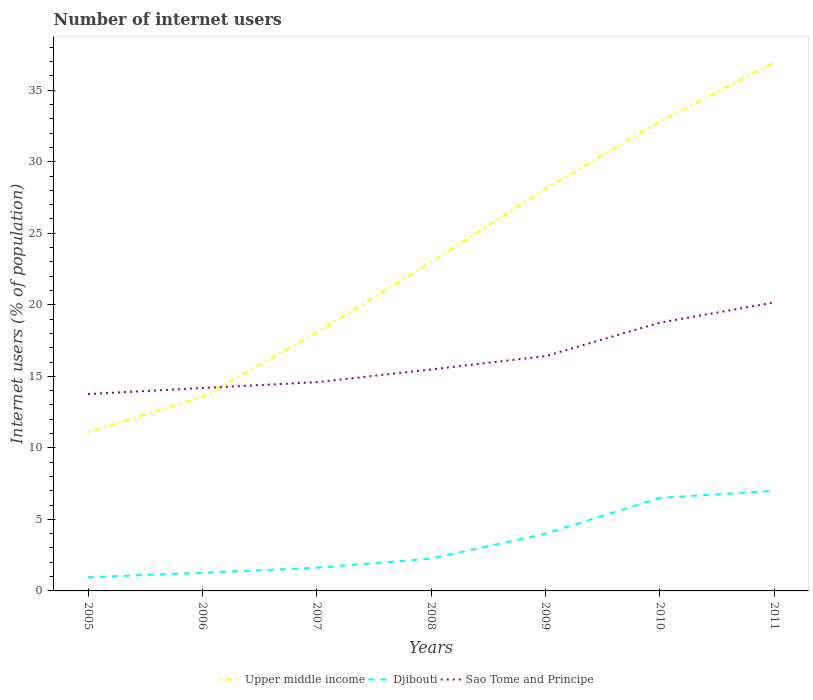Is the number of lines equal to the number of legend labels?
Make the answer very short. Yes. Across all years, what is the maximum number of internet users in Sao Tome and Principe?
Ensure brevity in your answer.  13.76. What is the total number of internet users in Djibouti in the graph?
Provide a short and direct response. -1.74. What is the difference between the highest and the second highest number of internet users in Upper middle income?
Give a very brief answer. 25.86. What is the difference between the highest and the lowest number of internet users in Sao Tome and Principe?
Your answer should be compact. 3. How many lines are there?
Offer a terse response. 3. How many years are there in the graph?
Give a very brief answer. 7. Are the values on the major ticks of Y-axis written in scientific E-notation?
Provide a short and direct response. No. Does the graph contain grids?
Your answer should be very brief. No. What is the title of the graph?
Provide a short and direct response. Number of internet users. What is the label or title of the X-axis?
Offer a very short reply. Years. What is the label or title of the Y-axis?
Your response must be concise. Internet users (% of population). What is the Internet users (% of population) in Upper middle income in 2005?
Give a very brief answer. 11.08. What is the Internet users (% of population) in Djibouti in 2005?
Make the answer very short. 0.95. What is the Internet users (% of population) in Sao Tome and Principe in 2005?
Give a very brief answer. 13.76. What is the Internet users (% of population) in Upper middle income in 2006?
Provide a short and direct response. 13.56. What is the Internet users (% of population) of Djibouti in 2006?
Provide a short and direct response. 1.27. What is the Internet users (% of population) in Sao Tome and Principe in 2006?
Make the answer very short. 14.18. What is the Internet users (% of population) of Upper middle income in 2007?
Ensure brevity in your answer.  18.05. What is the Internet users (% of population) in Djibouti in 2007?
Give a very brief answer. 1.62. What is the Internet users (% of population) in Sao Tome and Principe in 2007?
Provide a succinct answer. 14.59. What is the Internet users (% of population) of Upper middle income in 2008?
Your response must be concise. 22.99. What is the Internet users (% of population) of Djibouti in 2008?
Ensure brevity in your answer.  2.26. What is the Internet users (% of population) in Sao Tome and Principe in 2008?
Keep it short and to the point. 15.48. What is the Internet users (% of population) in Upper middle income in 2009?
Make the answer very short. 28.1. What is the Internet users (% of population) of Sao Tome and Principe in 2009?
Provide a succinct answer. 16.41. What is the Internet users (% of population) in Upper middle income in 2010?
Make the answer very short. 32.81. What is the Internet users (% of population) in Sao Tome and Principe in 2010?
Make the answer very short. 18.75. What is the Internet users (% of population) of Upper middle income in 2011?
Offer a terse response. 36.95. What is the Internet users (% of population) of Djibouti in 2011?
Make the answer very short. 7. What is the Internet users (% of population) in Sao Tome and Principe in 2011?
Your answer should be compact. 20.16. Across all years, what is the maximum Internet users (% of population) of Upper middle income?
Provide a short and direct response. 36.95. Across all years, what is the maximum Internet users (% of population) of Djibouti?
Offer a very short reply. 7. Across all years, what is the maximum Internet users (% of population) in Sao Tome and Principe?
Your answer should be very brief. 20.16. Across all years, what is the minimum Internet users (% of population) in Upper middle income?
Your answer should be compact. 11.08. Across all years, what is the minimum Internet users (% of population) of Djibouti?
Offer a very short reply. 0.95. Across all years, what is the minimum Internet users (% of population) of Sao Tome and Principe?
Give a very brief answer. 13.76. What is the total Internet users (% of population) of Upper middle income in the graph?
Offer a very short reply. 163.54. What is the total Internet users (% of population) in Djibouti in the graph?
Give a very brief answer. 23.6. What is the total Internet users (% of population) in Sao Tome and Principe in the graph?
Offer a terse response. 113.33. What is the difference between the Internet users (% of population) of Upper middle income in 2005 and that in 2006?
Ensure brevity in your answer.  -2.47. What is the difference between the Internet users (% of population) of Djibouti in 2005 and that in 2006?
Your answer should be very brief. -0.32. What is the difference between the Internet users (% of population) of Sao Tome and Principe in 2005 and that in 2006?
Ensure brevity in your answer.  -0.42. What is the difference between the Internet users (% of population) in Upper middle income in 2005 and that in 2007?
Your response must be concise. -6.97. What is the difference between the Internet users (% of population) in Djibouti in 2005 and that in 2007?
Your answer should be very brief. -0.67. What is the difference between the Internet users (% of population) in Sao Tome and Principe in 2005 and that in 2007?
Make the answer very short. -0.83. What is the difference between the Internet users (% of population) of Upper middle income in 2005 and that in 2008?
Ensure brevity in your answer.  -11.91. What is the difference between the Internet users (% of population) of Djibouti in 2005 and that in 2008?
Provide a short and direct response. -1.31. What is the difference between the Internet users (% of population) of Sao Tome and Principe in 2005 and that in 2008?
Offer a very short reply. -1.72. What is the difference between the Internet users (% of population) in Upper middle income in 2005 and that in 2009?
Ensure brevity in your answer.  -17.02. What is the difference between the Internet users (% of population) in Djibouti in 2005 and that in 2009?
Your answer should be very brief. -3.05. What is the difference between the Internet users (% of population) of Sao Tome and Principe in 2005 and that in 2009?
Ensure brevity in your answer.  -2.65. What is the difference between the Internet users (% of population) in Upper middle income in 2005 and that in 2010?
Keep it short and to the point. -21.72. What is the difference between the Internet users (% of population) in Djibouti in 2005 and that in 2010?
Make the answer very short. -5.55. What is the difference between the Internet users (% of population) of Sao Tome and Principe in 2005 and that in 2010?
Your response must be concise. -4.99. What is the difference between the Internet users (% of population) of Upper middle income in 2005 and that in 2011?
Offer a very short reply. -25.86. What is the difference between the Internet users (% of population) of Djibouti in 2005 and that in 2011?
Your response must be concise. -6.05. What is the difference between the Internet users (% of population) in Sao Tome and Principe in 2005 and that in 2011?
Make the answer very short. -6.4. What is the difference between the Internet users (% of population) of Upper middle income in 2006 and that in 2007?
Give a very brief answer. -4.49. What is the difference between the Internet users (% of population) in Djibouti in 2006 and that in 2007?
Provide a succinct answer. -0.35. What is the difference between the Internet users (% of population) of Sao Tome and Principe in 2006 and that in 2007?
Offer a very short reply. -0.41. What is the difference between the Internet users (% of population) in Upper middle income in 2006 and that in 2008?
Your answer should be compact. -9.43. What is the difference between the Internet users (% of population) in Djibouti in 2006 and that in 2008?
Offer a terse response. -0.99. What is the difference between the Internet users (% of population) in Sao Tome and Principe in 2006 and that in 2008?
Provide a succinct answer. -1.3. What is the difference between the Internet users (% of population) in Upper middle income in 2006 and that in 2009?
Provide a short and direct response. -14.54. What is the difference between the Internet users (% of population) in Djibouti in 2006 and that in 2009?
Your response must be concise. -2.73. What is the difference between the Internet users (% of population) of Sao Tome and Principe in 2006 and that in 2009?
Make the answer very short. -2.23. What is the difference between the Internet users (% of population) in Upper middle income in 2006 and that in 2010?
Offer a terse response. -19.25. What is the difference between the Internet users (% of population) of Djibouti in 2006 and that in 2010?
Offer a very short reply. -5.23. What is the difference between the Internet users (% of population) in Sao Tome and Principe in 2006 and that in 2010?
Provide a short and direct response. -4.57. What is the difference between the Internet users (% of population) of Upper middle income in 2006 and that in 2011?
Your answer should be very brief. -23.39. What is the difference between the Internet users (% of population) in Djibouti in 2006 and that in 2011?
Offer a very short reply. -5.73. What is the difference between the Internet users (% of population) in Sao Tome and Principe in 2006 and that in 2011?
Keep it short and to the point. -5.98. What is the difference between the Internet users (% of population) of Upper middle income in 2007 and that in 2008?
Offer a terse response. -4.94. What is the difference between the Internet users (% of population) in Djibouti in 2007 and that in 2008?
Provide a succinct answer. -0.64. What is the difference between the Internet users (% of population) in Sao Tome and Principe in 2007 and that in 2008?
Your answer should be compact. -0.89. What is the difference between the Internet users (% of population) of Upper middle income in 2007 and that in 2009?
Ensure brevity in your answer.  -10.05. What is the difference between the Internet users (% of population) in Djibouti in 2007 and that in 2009?
Give a very brief answer. -2.38. What is the difference between the Internet users (% of population) of Sao Tome and Principe in 2007 and that in 2009?
Offer a very short reply. -1.82. What is the difference between the Internet users (% of population) of Upper middle income in 2007 and that in 2010?
Keep it short and to the point. -14.76. What is the difference between the Internet users (% of population) in Djibouti in 2007 and that in 2010?
Offer a terse response. -4.88. What is the difference between the Internet users (% of population) in Sao Tome and Principe in 2007 and that in 2010?
Your answer should be compact. -4.16. What is the difference between the Internet users (% of population) in Upper middle income in 2007 and that in 2011?
Your answer should be compact. -18.9. What is the difference between the Internet users (% of population) of Djibouti in 2007 and that in 2011?
Offer a terse response. -5.38. What is the difference between the Internet users (% of population) in Sao Tome and Principe in 2007 and that in 2011?
Provide a short and direct response. -5.57. What is the difference between the Internet users (% of population) of Upper middle income in 2008 and that in 2009?
Offer a terse response. -5.11. What is the difference between the Internet users (% of population) in Djibouti in 2008 and that in 2009?
Provide a succinct answer. -1.74. What is the difference between the Internet users (% of population) in Sao Tome and Principe in 2008 and that in 2009?
Your answer should be very brief. -0.93. What is the difference between the Internet users (% of population) of Upper middle income in 2008 and that in 2010?
Keep it short and to the point. -9.82. What is the difference between the Internet users (% of population) of Djibouti in 2008 and that in 2010?
Your answer should be compact. -4.24. What is the difference between the Internet users (% of population) of Sao Tome and Principe in 2008 and that in 2010?
Make the answer very short. -3.27. What is the difference between the Internet users (% of population) of Upper middle income in 2008 and that in 2011?
Provide a succinct answer. -13.96. What is the difference between the Internet users (% of population) in Djibouti in 2008 and that in 2011?
Give a very brief answer. -4.74. What is the difference between the Internet users (% of population) in Sao Tome and Principe in 2008 and that in 2011?
Ensure brevity in your answer.  -4.68. What is the difference between the Internet users (% of population) in Upper middle income in 2009 and that in 2010?
Keep it short and to the point. -4.7. What is the difference between the Internet users (% of population) in Sao Tome and Principe in 2009 and that in 2010?
Provide a short and direct response. -2.34. What is the difference between the Internet users (% of population) in Upper middle income in 2009 and that in 2011?
Your response must be concise. -8.84. What is the difference between the Internet users (% of population) of Djibouti in 2009 and that in 2011?
Keep it short and to the point. -3. What is the difference between the Internet users (% of population) in Sao Tome and Principe in 2009 and that in 2011?
Make the answer very short. -3.75. What is the difference between the Internet users (% of population) of Upper middle income in 2010 and that in 2011?
Give a very brief answer. -4.14. What is the difference between the Internet users (% of population) in Sao Tome and Principe in 2010 and that in 2011?
Offer a terse response. -1.41. What is the difference between the Internet users (% of population) of Upper middle income in 2005 and the Internet users (% of population) of Djibouti in 2006?
Your answer should be very brief. 9.81. What is the difference between the Internet users (% of population) of Upper middle income in 2005 and the Internet users (% of population) of Sao Tome and Principe in 2006?
Give a very brief answer. -3.1. What is the difference between the Internet users (% of population) in Djibouti in 2005 and the Internet users (% of population) in Sao Tome and Principe in 2006?
Ensure brevity in your answer.  -13.23. What is the difference between the Internet users (% of population) of Upper middle income in 2005 and the Internet users (% of population) of Djibouti in 2007?
Your answer should be very brief. 9.46. What is the difference between the Internet users (% of population) of Upper middle income in 2005 and the Internet users (% of population) of Sao Tome and Principe in 2007?
Your answer should be very brief. -3.51. What is the difference between the Internet users (% of population) of Djibouti in 2005 and the Internet users (% of population) of Sao Tome and Principe in 2007?
Ensure brevity in your answer.  -13.64. What is the difference between the Internet users (% of population) in Upper middle income in 2005 and the Internet users (% of population) in Djibouti in 2008?
Offer a very short reply. 8.82. What is the difference between the Internet users (% of population) in Upper middle income in 2005 and the Internet users (% of population) in Sao Tome and Principe in 2008?
Provide a succinct answer. -4.4. What is the difference between the Internet users (% of population) in Djibouti in 2005 and the Internet users (% of population) in Sao Tome and Principe in 2008?
Make the answer very short. -14.53. What is the difference between the Internet users (% of population) in Upper middle income in 2005 and the Internet users (% of population) in Djibouti in 2009?
Provide a succinct answer. 7.08. What is the difference between the Internet users (% of population) in Upper middle income in 2005 and the Internet users (% of population) in Sao Tome and Principe in 2009?
Your response must be concise. -5.33. What is the difference between the Internet users (% of population) of Djibouti in 2005 and the Internet users (% of population) of Sao Tome and Principe in 2009?
Give a very brief answer. -15.46. What is the difference between the Internet users (% of population) in Upper middle income in 2005 and the Internet users (% of population) in Djibouti in 2010?
Make the answer very short. 4.58. What is the difference between the Internet users (% of population) in Upper middle income in 2005 and the Internet users (% of population) in Sao Tome and Principe in 2010?
Provide a succinct answer. -7.67. What is the difference between the Internet users (% of population) of Djibouti in 2005 and the Internet users (% of population) of Sao Tome and Principe in 2010?
Offer a very short reply. -17.8. What is the difference between the Internet users (% of population) in Upper middle income in 2005 and the Internet users (% of population) in Djibouti in 2011?
Ensure brevity in your answer.  4.08. What is the difference between the Internet users (% of population) of Upper middle income in 2005 and the Internet users (% of population) of Sao Tome and Principe in 2011?
Your answer should be compact. -9.08. What is the difference between the Internet users (% of population) of Djibouti in 2005 and the Internet users (% of population) of Sao Tome and Principe in 2011?
Offer a very short reply. -19.21. What is the difference between the Internet users (% of population) in Upper middle income in 2006 and the Internet users (% of population) in Djibouti in 2007?
Ensure brevity in your answer.  11.94. What is the difference between the Internet users (% of population) of Upper middle income in 2006 and the Internet users (% of population) of Sao Tome and Principe in 2007?
Your answer should be very brief. -1.03. What is the difference between the Internet users (% of population) in Djibouti in 2006 and the Internet users (% of population) in Sao Tome and Principe in 2007?
Provide a succinct answer. -13.32. What is the difference between the Internet users (% of population) of Upper middle income in 2006 and the Internet users (% of population) of Djibouti in 2008?
Offer a very short reply. 11.3. What is the difference between the Internet users (% of population) in Upper middle income in 2006 and the Internet users (% of population) in Sao Tome and Principe in 2008?
Your answer should be compact. -1.92. What is the difference between the Internet users (% of population) in Djibouti in 2006 and the Internet users (% of population) in Sao Tome and Principe in 2008?
Make the answer very short. -14.21. What is the difference between the Internet users (% of population) of Upper middle income in 2006 and the Internet users (% of population) of Djibouti in 2009?
Your response must be concise. 9.56. What is the difference between the Internet users (% of population) of Upper middle income in 2006 and the Internet users (% of population) of Sao Tome and Principe in 2009?
Your answer should be compact. -2.85. What is the difference between the Internet users (% of population) of Djibouti in 2006 and the Internet users (% of population) of Sao Tome and Principe in 2009?
Offer a very short reply. -15.14. What is the difference between the Internet users (% of population) of Upper middle income in 2006 and the Internet users (% of population) of Djibouti in 2010?
Provide a succinct answer. 7.06. What is the difference between the Internet users (% of population) in Upper middle income in 2006 and the Internet users (% of population) in Sao Tome and Principe in 2010?
Your answer should be compact. -5.19. What is the difference between the Internet users (% of population) of Djibouti in 2006 and the Internet users (% of population) of Sao Tome and Principe in 2010?
Your response must be concise. -17.48. What is the difference between the Internet users (% of population) of Upper middle income in 2006 and the Internet users (% of population) of Djibouti in 2011?
Your response must be concise. 6.56. What is the difference between the Internet users (% of population) of Upper middle income in 2006 and the Internet users (% of population) of Sao Tome and Principe in 2011?
Your response must be concise. -6.6. What is the difference between the Internet users (% of population) of Djibouti in 2006 and the Internet users (% of population) of Sao Tome and Principe in 2011?
Make the answer very short. -18.89. What is the difference between the Internet users (% of population) of Upper middle income in 2007 and the Internet users (% of population) of Djibouti in 2008?
Provide a short and direct response. 15.79. What is the difference between the Internet users (% of population) in Upper middle income in 2007 and the Internet users (% of population) in Sao Tome and Principe in 2008?
Offer a very short reply. 2.57. What is the difference between the Internet users (% of population) of Djibouti in 2007 and the Internet users (% of population) of Sao Tome and Principe in 2008?
Keep it short and to the point. -13.86. What is the difference between the Internet users (% of population) in Upper middle income in 2007 and the Internet users (% of population) in Djibouti in 2009?
Give a very brief answer. 14.05. What is the difference between the Internet users (% of population) of Upper middle income in 2007 and the Internet users (% of population) of Sao Tome and Principe in 2009?
Ensure brevity in your answer.  1.64. What is the difference between the Internet users (% of population) of Djibouti in 2007 and the Internet users (% of population) of Sao Tome and Principe in 2009?
Your answer should be very brief. -14.79. What is the difference between the Internet users (% of population) in Upper middle income in 2007 and the Internet users (% of population) in Djibouti in 2010?
Make the answer very short. 11.55. What is the difference between the Internet users (% of population) in Upper middle income in 2007 and the Internet users (% of population) in Sao Tome and Principe in 2010?
Your response must be concise. -0.7. What is the difference between the Internet users (% of population) in Djibouti in 2007 and the Internet users (% of population) in Sao Tome and Principe in 2010?
Ensure brevity in your answer.  -17.13. What is the difference between the Internet users (% of population) of Upper middle income in 2007 and the Internet users (% of population) of Djibouti in 2011?
Ensure brevity in your answer.  11.05. What is the difference between the Internet users (% of population) in Upper middle income in 2007 and the Internet users (% of population) in Sao Tome and Principe in 2011?
Provide a succinct answer. -2.11. What is the difference between the Internet users (% of population) of Djibouti in 2007 and the Internet users (% of population) of Sao Tome and Principe in 2011?
Provide a short and direct response. -18.54. What is the difference between the Internet users (% of population) of Upper middle income in 2008 and the Internet users (% of population) of Djibouti in 2009?
Provide a succinct answer. 18.99. What is the difference between the Internet users (% of population) of Upper middle income in 2008 and the Internet users (% of population) of Sao Tome and Principe in 2009?
Keep it short and to the point. 6.58. What is the difference between the Internet users (% of population) of Djibouti in 2008 and the Internet users (% of population) of Sao Tome and Principe in 2009?
Provide a succinct answer. -14.15. What is the difference between the Internet users (% of population) in Upper middle income in 2008 and the Internet users (% of population) in Djibouti in 2010?
Make the answer very short. 16.49. What is the difference between the Internet users (% of population) in Upper middle income in 2008 and the Internet users (% of population) in Sao Tome and Principe in 2010?
Your answer should be very brief. 4.24. What is the difference between the Internet users (% of population) of Djibouti in 2008 and the Internet users (% of population) of Sao Tome and Principe in 2010?
Ensure brevity in your answer.  -16.49. What is the difference between the Internet users (% of population) in Upper middle income in 2008 and the Internet users (% of population) in Djibouti in 2011?
Your answer should be compact. 15.99. What is the difference between the Internet users (% of population) in Upper middle income in 2008 and the Internet users (% of population) in Sao Tome and Principe in 2011?
Ensure brevity in your answer.  2.83. What is the difference between the Internet users (% of population) of Djibouti in 2008 and the Internet users (% of population) of Sao Tome and Principe in 2011?
Give a very brief answer. -17.9. What is the difference between the Internet users (% of population) of Upper middle income in 2009 and the Internet users (% of population) of Djibouti in 2010?
Offer a very short reply. 21.6. What is the difference between the Internet users (% of population) of Upper middle income in 2009 and the Internet users (% of population) of Sao Tome and Principe in 2010?
Make the answer very short. 9.35. What is the difference between the Internet users (% of population) of Djibouti in 2009 and the Internet users (% of population) of Sao Tome and Principe in 2010?
Provide a succinct answer. -14.75. What is the difference between the Internet users (% of population) in Upper middle income in 2009 and the Internet users (% of population) in Djibouti in 2011?
Keep it short and to the point. 21.1. What is the difference between the Internet users (% of population) of Upper middle income in 2009 and the Internet users (% of population) of Sao Tome and Principe in 2011?
Offer a terse response. 7.94. What is the difference between the Internet users (% of population) of Djibouti in 2009 and the Internet users (% of population) of Sao Tome and Principe in 2011?
Ensure brevity in your answer.  -16.16. What is the difference between the Internet users (% of population) in Upper middle income in 2010 and the Internet users (% of population) in Djibouti in 2011?
Offer a terse response. 25.81. What is the difference between the Internet users (% of population) in Upper middle income in 2010 and the Internet users (% of population) in Sao Tome and Principe in 2011?
Keep it short and to the point. 12.64. What is the difference between the Internet users (% of population) of Djibouti in 2010 and the Internet users (% of population) of Sao Tome and Principe in 2011?
Offer a terse response. -13.66. What is the average Internet users (% of population) in Upper middle income per year?
Your response must be concise. 23.36. What is the average Internet users (% of population) in Djibouti per year?
Make the answer very short. 3.37. What is the average Internet users (% of population) of Sao Tome and Principe per year?
Ensure brevity in your answer.  16.19. In the year 2005, what is the difference between the Internet users (% of population) of Upper middle income and Internet users (% of population) of Djibouti?
Provide a short and direct response. 10.13. In the year 2005, what is the difference between the Internet users (% of population) of Upper middle income and Internet users (% of population) of Sao Tome and Principe?
Provide a succinct answer. -2.67. In the year 2005, what is the difference between the Internet users (% of population) of Djibouti and Internet users (% of population) of Sao Tome and Principe?
Offer a terse response. -12.81. In the year 2006, what is the difference between the Internet users (% of population) in Upper middle income and Internet users (% of population) in Djibouti?
Your answer should be very brief. 12.29. In the year 2006, what is the difference between the Internet users (% of population) of Upper middle income and Internet users (% of population) of Sao Tome and Principe?
Your response must be concise. -0.62. In the year 2006, what is the difference between the Internet users (% of population) of Djibouti and Internet users (% of population) of Sao Tome and Principe?
Offer a terse response. -12.91. In the year 2007, what is the difference between the Internet users (% of population) in Upper middle income and Internet users (% of population) in Djibouti?
Offer a very short reply. 16.43. In the year 2007, what is the difference between the Internet users (% of population) of Upper middle income and Internet users (% of population) of Sao Tome and Principe?
Provide a short and direct response. 3.46. In the year 2007, what is the difference between the Internet users (% of population) of Djibouti and Internet users (% of population) of Sao Tome and Principe?
Your answer should be compact. -12.97. In the year 2008, what is the difference between the Internet users (% of population) of Upper middle income and Internet users (% of population) of Djibouti?
Make the answer very short. 20.73. In the year 2008, what is the difference between the Internet users (% of population) in Upper middle income and Internet users (% of population) in Sao Tome and Principe?
Provide a succinct answer. 7.51. In the year 2008, what is the difference between the Internet users (% of population) of Djibouti and Internet users (% of population) of Sao Tome and Principe?
Offer a very short reply. -13.22. In the year 2009, what is the difference between the Internet users (% of population) in Upper middle income and Internet users (% of population) in Djibouti?
Give a very brief answer. 24.1. In the year 2009, what is the difference between the Internet users (% of population) of Upper middle income and Internet users (% of population) of Sao Tome and Principe?
Your answer should be very brief. 11.69. In the year 2009, what is the difference between the Internet users (% of population) in Djibouti and Internet users (% of population) in Sao Tome and Principe?
Your answer should be very brief. -12.41. In the year 2010, what is the difference between the Internet users (% of population) of Upper middle income and Internet users (% of population) of Djibouti?
Your response must be concise. 26.31. In the year 2010, what is the difference between the Internet users (% of population) in Upper middle income and Internet users (% of population) in Sao Tome and Principe?
Your answer should be compact. 14.06. In the year 2010, what is the difference between the Internet users (% of population) of Djibouti and Internet users (% of population) of Sao Tome and Principe?
Make the answer very short. -12.25. In the year 2011, what is the difference between the Internet users (% of population) of Upper middle income and Internet users (% of population) of Djibouti?
Your answer should be very brief. 29.95. In the year 2011, what is the difference between the Internet users (% of population) of Upper middle income and Internet users (% of population) of Sao Tome and Principe?
Offer a very short reply. 16.78. In the year 2011, what is the difference between the Internet users (% of population) of Djibouti and Internet users (% of population) of Sao Tome and Principe?
Provide a succinct answer. -13.16. What is the ratio of the Internet users (% of population) of Upper middle income in 2005 to that in 2006?
Make the answer very short. 0.82. What is the ratio of the Internet users (% of population) in Djibouti in 2005 to that in 2006?
Your response must be concise. 0.75. What is the ratio of the Internet users (% of population) of Sao Tome and Principe in 2005 to that in 2006?
Ensure brevity in your answer.  0.97. What is the ratio of the Internet users (% of population) of Upper middle income in 2005 to that in 2007?
Offer a very short reply. 0.61. What is the ratio of the Internet users (% of population) in Djibouti in 2005 to that in 2007?
Ensure brevity in your answer.  0.59. What is the ratio of the Internet users (% of population) of Sao Tome and Principe in 2005 to that in 2007?
Make the answer very short. 0.94. What is the ratio of the Internet users (% of population) of Upper middle income in 2005 to that in 2008?
Ensure brevity in your answer.  0.48. What is the ratio of the Internet users (% of population) of Djibouti in 2005 to that in 2008?
Provide a short and direct response. 0.42. What is the ratio of the Internet users (% of population) in Upper middle income in 2005 to that in 2009?
Make the answer very short. 0.39. What is the ratio of the Internet users (% of population) of Djibouti in 2005 to that in 2009?
Your response must be concise. 0.24. What is the ratio of the Internet users (% of population) in Sao Tome and Principe in 2005 to that in 2009?
Your answer should be very brief. 0.84. What is the ratio of the Internet users (% of population) in Upper middle income in 2005 to that in 2010?
Keep it short and to the point. 0.34. What is the ratio of the Internet users (% of population) of Djibouti in 2005 to that in 2010?
Offer a very short reply. 0.15. What is the ratio of the Internet users (% of population) in Sao Tome and Principe in 2005 to that in 2010?
Your answer should be compact. 0.73. What is the ratio of the Internet users (% of population) of Djibouti in 2005 to that in 2011?
Your response must be concise. 0.14. What is the ratio of the Internet users (% of population) in Sao Tome and Principe in 2005 to that in 2011?
Ensure brevity in your answer.  0.68. What is the ratio of the Internet users (% of population) of Upper middle income in 2006 to that in 2007?
Your answer should be very brief. 0.75. What is the ratio of the Internet users (% of population) of Djibouti in 2006 to that in 2007?
Your response must be concise. 0.78. What is the ratio of the Internet users (% of population) of Sao Tome and Principe in 2006 to that in 2007?
Make the answer very short. 0.97. What is the ratio of the Internet users (% of population) of Upper middle income in 2006 to that in 2008?
Give a very brief answer. 0.59. What is the ratio of the Internet users (% of population) in Djibouti in 2006 to that in 2008?
Give a very brief answer. 0.56. What is the ratio of the Internet users (% of population) in Sao Tome and Principe in 2006 to that in 2008?
Your answer should be compact. 0.92. What is the ratio of the Internet users (% of population) of Upper middle income in 2006 to that in 2009?
Offer a very short reply. 0.48. What is the ratio of the Internet users (% of population) of Djibouti in 2006 to that in 2009?
Your answer should be very brief. 0.32. What is the ratio of the Internet users (% of population) of Sao Tome and Principe in 2006 to that in 2009?
Your answer should be compact. 0.86. What is the ratio of the Internet users (% of population) in Upper middle income in 2006 to that in 2010?
Give a very brief answer. 0.41. What is the ratio of the Internet users (% of population) of Djibouti in 2006 to that in 2010?
Give a very brief answer. 0.2. What is the ratio of the Internet users (% of population) in Sao Tome and Principe in 2006 to that in 2010?
Provide a short and direct response. 0.76. What is the ratio of the Internet users (% of population) in Upper middle income in 2006 to that in 2011?
Your response must be concise. 0.37. What is the ratio of the Internet users (% of population) of Djibouti in 2006 to that in 2011?
Offer a very short reply. 0.18. What is the ratio of the Internet users (% of population) of Sao Tome and Principe in 2006 to that in 2011?
Give a very brief answer. 0.7. What is the ratio of the Internet users (% of population) of Upper middle income in 2007 to that in 2008?
Your response must be concise. 0.79. What is the ratio of the Internet users (% of population) of Djibouti in 2007 to that in 2008?
Your answer should be very brief. 0.72. What is the ratio of the Internet users (% of population) of Sao Tome and Principe in 2007 to that in 2008?
Offer a terse response. 0.94. What is the ratio of the Internet users (% of population) in Upper middle income in 2007 to that in 2009?
Provide a succinct answer. 0.64. What is the ratio of the Internet users (% of population) of Djibouti in 2007 to that in 2009?
Keep it short and to the point. 0.41. What is the ratio of the Internet users (% of population) in Sao Tome and Principe in 2007 to that in 2009?
Your answer should be very brief. 0.89. What is the ratio of the Internet users (% of population) in Upper middle income in 2007 to that in 2010?
Offer a terse response. 0.55. What is the ratio of the Internet users (% of population) in Djibouti in 2007 to that in 2010?
Offer a very short reply. 0.25. What is the ratio of the Internet users (% of population) of Sao Tome and Principe in 2007 to that in 2010?
Provide a succinct answer. 0.78. What is the ratio of the Internet users (% of population) of Upper middle income in 2007 to that in 2011?
Make the answer very short. 0.49. What is the ratio of the Internet users (% of population) in Djibouti in 2007 to that in 2011?
Offer a terse response. 0.23. What is the ratio of the Internet users (% of population) in Sao Tome and Principe in 2007 to that in 2011?
Ensure brevity in your answer.  0.72. What is the ratio of the Internet users (% of population) of Upper middle income in 2008 to that in 2009?
Your answer should be very brief. 0.82. What is the ratio of the Internet users (% of population) of Djibouti in 2008 to that in 2009?
Keep it short and to the point. 0.56. What is the ratio of the Internet users (% of population) in Sao Tome and Principe in 2008 to that in 2009?
Provide a short and direct response. 0.94. What is the ratio of the Internet users (% of population) in Upper middle income in 2008 to that in 2010?
Your answer should be compact. 0.7. What is the ratio of the Internet users (% of population) in Djibouti in 2008 to that in 2010?
Offer a very short reply. 0.35. What is the ratio of the Internet users (% of population) of Sao Tome and Principe in 2008 to that in 2010?
Your response must be concise. 0.83. What is the ratio of the Internet users (% of population) of Upper middle income in 2008 to that in 2011?
Your answer should be very brief. 0.62. What is the ratio of the Internet users (% of population) of Djibouti in 2008 to that in 2011?
Your response must be concise. 0.32. What is the ratio of the Internet users (% of population) in Sao Tome and Principe in 2008 to that in 2011?
Offer a very short reply. 0.77. What is the ratio of the Internet users (% of population) in Upper middle income in 2009 to that in 2010?
Ensure brevity in your answer.  0.86. What is the ratio of the Internet users (% of population) in Djibouti in 2009 to that in 2010?
Make the answer very short. 0.62. What is the ratio of the Internet users (% of population) in Sao Tome and Principe in 2009 to that in 2010?
Your answer should be compact. 0.88. What is the ratio of the Internet users (% of population) in Upper middle income in 2009 to that in 2011?
Keep it short and to the point. 0.76. What is the ratio of the Internet users (% of population) in Djibouti in 2009 to that in 2011?
Your answer should be very brief. 0.57. What is the ratio of the Internet users (% of population) of Sao Tome and Principe in 2009 to that in 2011?
Your answer should be compact. 0.81. What is the ratio of the Internet users (% of population) in Upper middle income in 2010 to that in 2011?
Ensure brevity in your answer.  0.89. What is the ratio of the Internet users (% of population) of Djibouti in 2010 to that in 2011?
Give a very brief answer. 0.93. What is the ratio of the Internet users (% of population) of Sao Tome and Principe in 2010 to that in 2011?
Your answer should be compact. 0.93. What is the difference between the highest and the second highest Internet users (% of population) of Upper middle income?
Ensure brevity in your answer.  4.14. What is the difference between the highest and the second highest Internet users (% of population) in Djibouti?
Offer a very short reply. 0.5. What is the difference between the highest and the second highest Internet users (% of population) in Sao Tome and Principe?
Give a very brief answer. 1.41. What is the difference between the highest and the lowest Internet users (% of population) in Upper middle income?
Make the answer very short. 25.86. What is the difference between the highest and the lowest Internet users (% of population) in Djibouti?
Your response must be concise. 6.05. What is the difference between the highest and the lowest Internet users (% of population) in Sao Tome and Principe?
Offer a terse response. 6.4. 